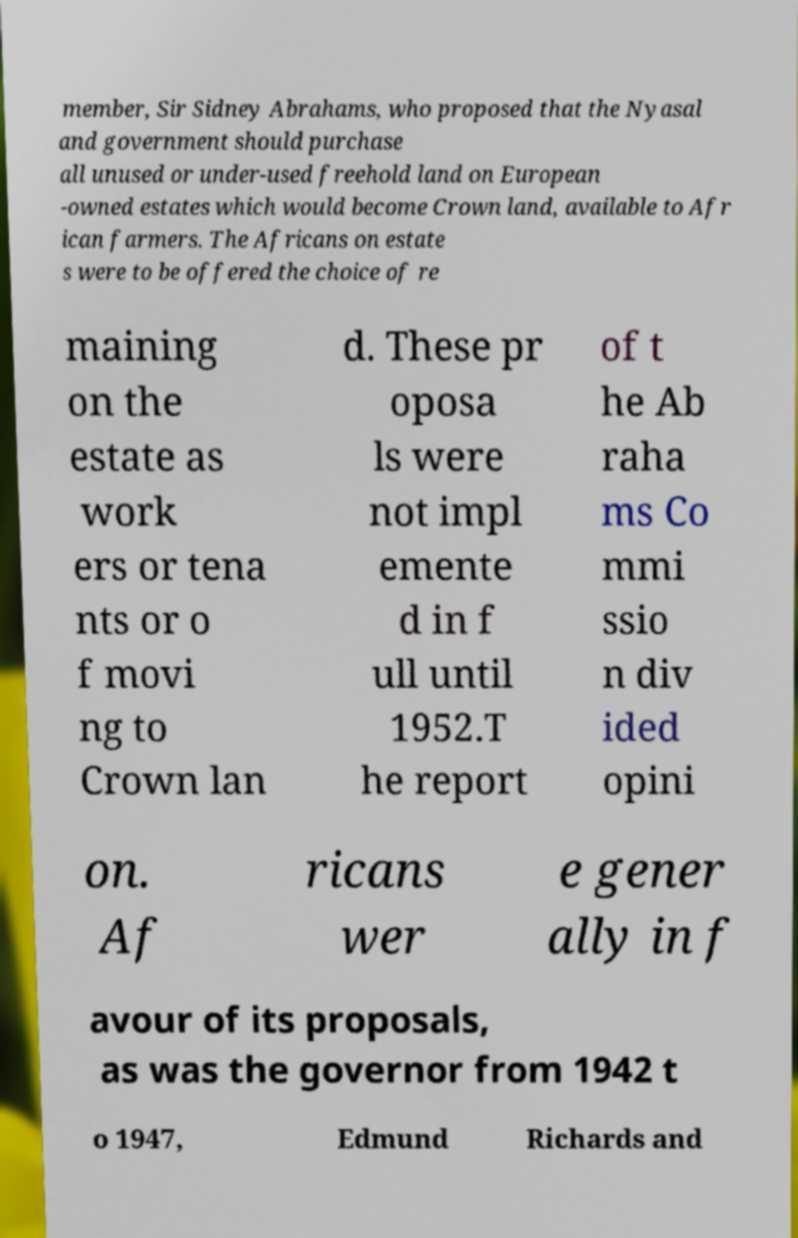Could you extract and type out the text from this image? member, Sir Sidney Abrahams, who proposed that the Nyasal and government should purchase all unused or under-used freehold land on European -owned estates which would become Crown land, available to Afr ican farmers. The Africans on estate s were to be offered the choice of re maining on the estate as work ers or tena nts or o f movi ng to Crown lan d. These pr oposa ls were not impl emente d in f ull until 1952.T he report of t he Ab raha ms Co mmi ssio n div ided opini on. Af ricans wer e gener ally in f avour of its proposals, as was the governor from 1942 t o 1947, Edmund Richards and 